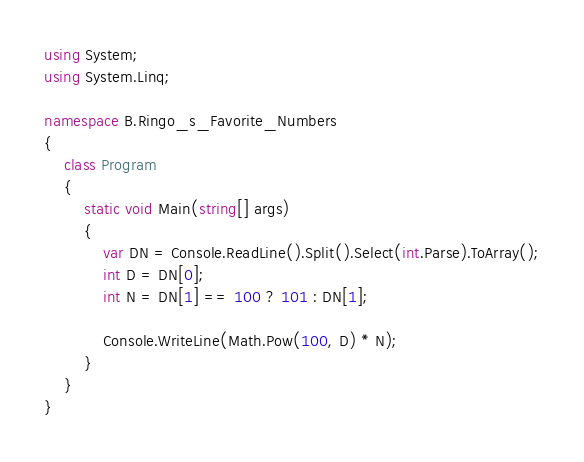<code> <loc_0><loc_0><loc_500><loc_500><_C#_>using System;
using System.Linq;

namespace B.Ringo_s_Favorite_Numbers
{
    class Program
    {
        static void Main(string[] args)
        {
            var DN = Console.ReadLine().Split().Select(int.Parse).ToArray();
            int D = DN[0];
            int N = DN[1] == 100 ? 101 : DN[1];

            Console.WriteLine(Math.Pow(100, D) * N);
        }
    }
}
</code> 